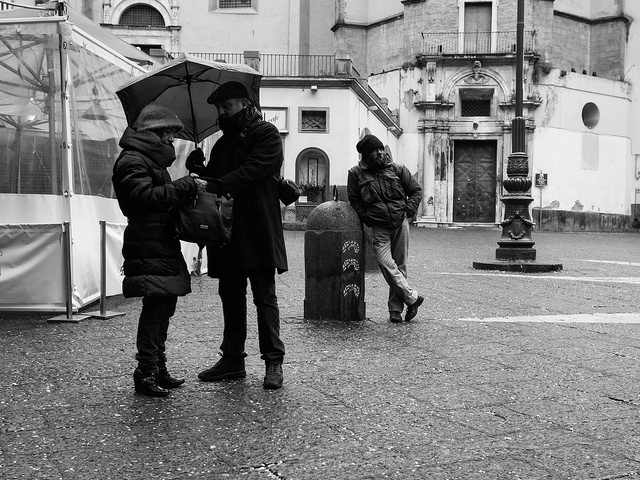Describe the objects in this image and their specific colors. I can see people in lightgray, black, gray, and darkgray tones, people in lightgray, black, gray, and darkgray tones, people in lightgray, black, gray, and darkgray tones, umbrella in lightgray, black, and darkgray tones, and handbag in lightgray, black, and gray tones in this image. 